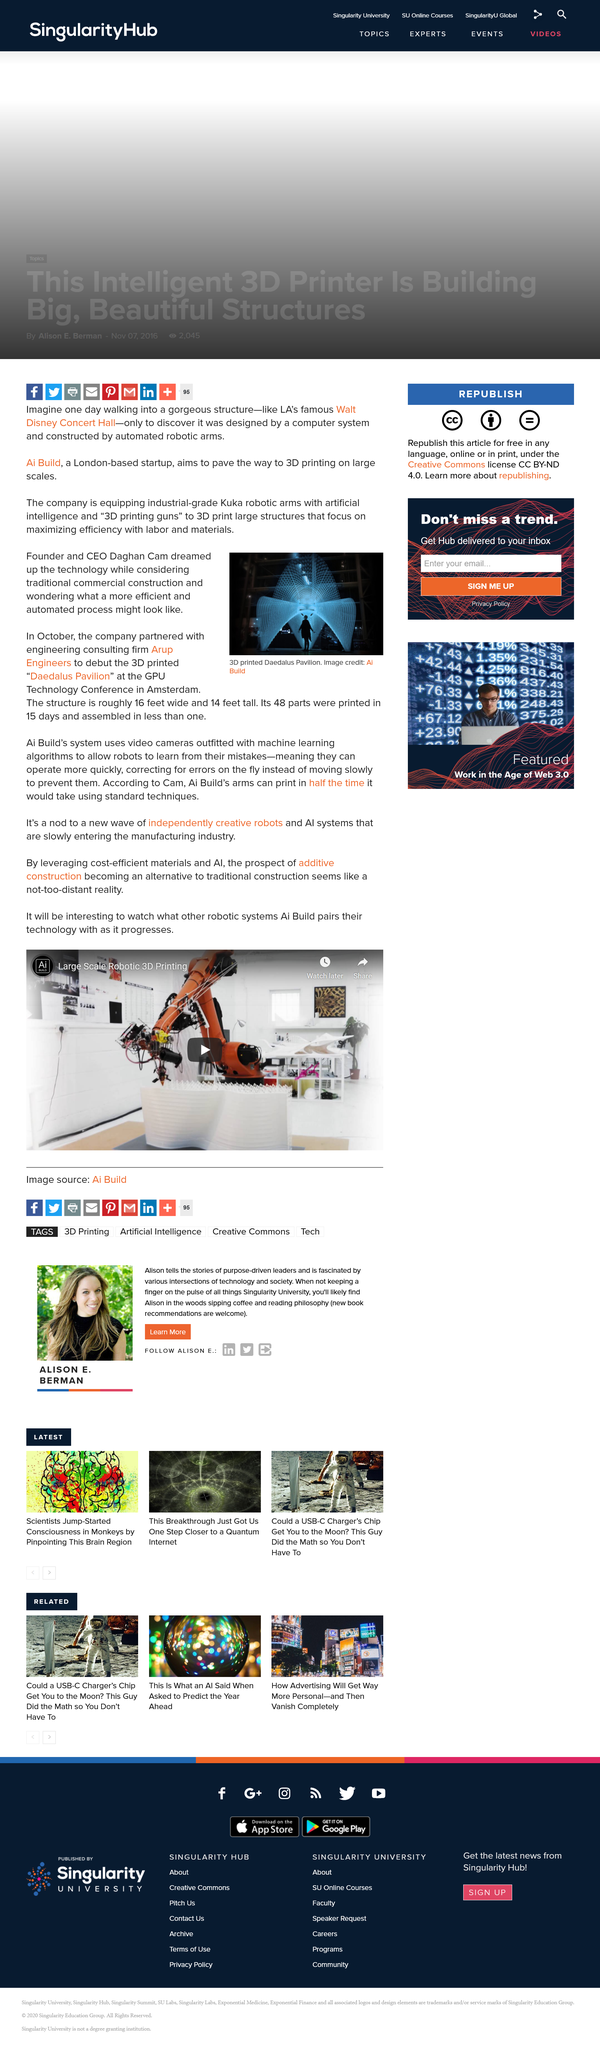Draw attention to some important aspects in this diagram. Daghan Cam is the founder and CEO of the company. The GPU Technology Conference is held in Amsterdam. The "Daedalus Pavilion" 3D printed structure is approximately 16 feet in width and 14 feet in height. 